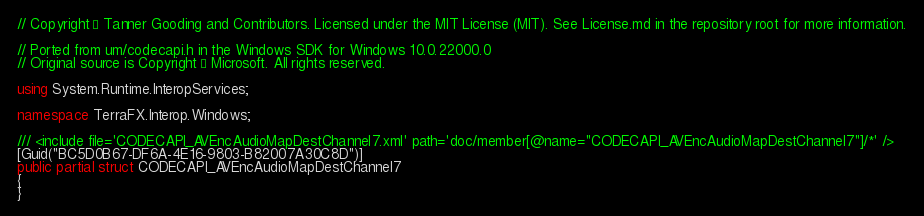<code> <loc_0><loc_0><loc_500><loc_500><_C#_>// Copyright © Tanner Gooding and Contributors. Licensed under the MIT License (MIT). See License.md in the repository root for more information.

// Ported from um/codecapi.h in the Windows SDK for Windows 10.0.22000.0
// Original source is Copyright © Microsoft. All rights reserved.

using System.Runtime.InteropServices;

namespace TerraFX.Interop.Windows;

/// <include file='CODECAPI_AVEncAudioMapDestChannel7.xml' path='doc/member[@name="CODECAPI_AVEncAudioMapDestChannel7"]/*' />
[Guid("BC5D0B67-DF6A-4E16-9803-B82007A30C8D")]
public partial struct CODECAPI_AVEncAudioMapDestChannel7
{
}
</code> 